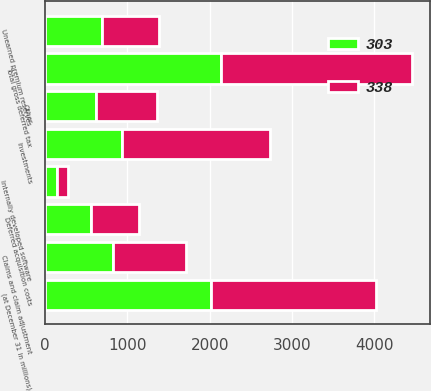Convert chart to OTSL. <chart><loc_0><loc_0><loc_500><loc_500><stacked_bar_chart><ecel><fcel>(at December 31 in millions)<fcel>Claims and claim adjustment<fcel>Unearned premium reserves<fcel>Other<fcel>Total gross deferred tax<fcel>Deferred acquisition costs<fcel>Investments<fcel>Internally developed software<nl><fcel>303<fcel>2013<fcel>825<fcel>693<fcel>621<fcel>2139<fcel>554<fcel>931<fcel>138<nl><fcel>338<fcel>2012<fcel>888<fcel>689<fcel>741<fcel>2318<fcel>590<fcel>1800<fcel>134<nl></chart> 